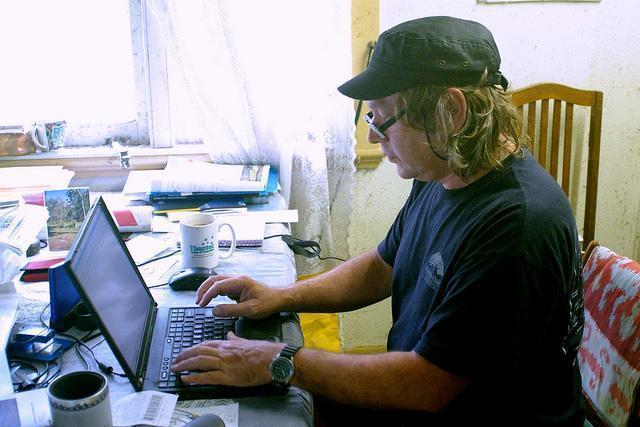Approximately what time is it?
Indicate the correct response by choosing from the four available options to answer the question.
Options: 925, 155, 1205, 255. 255. 